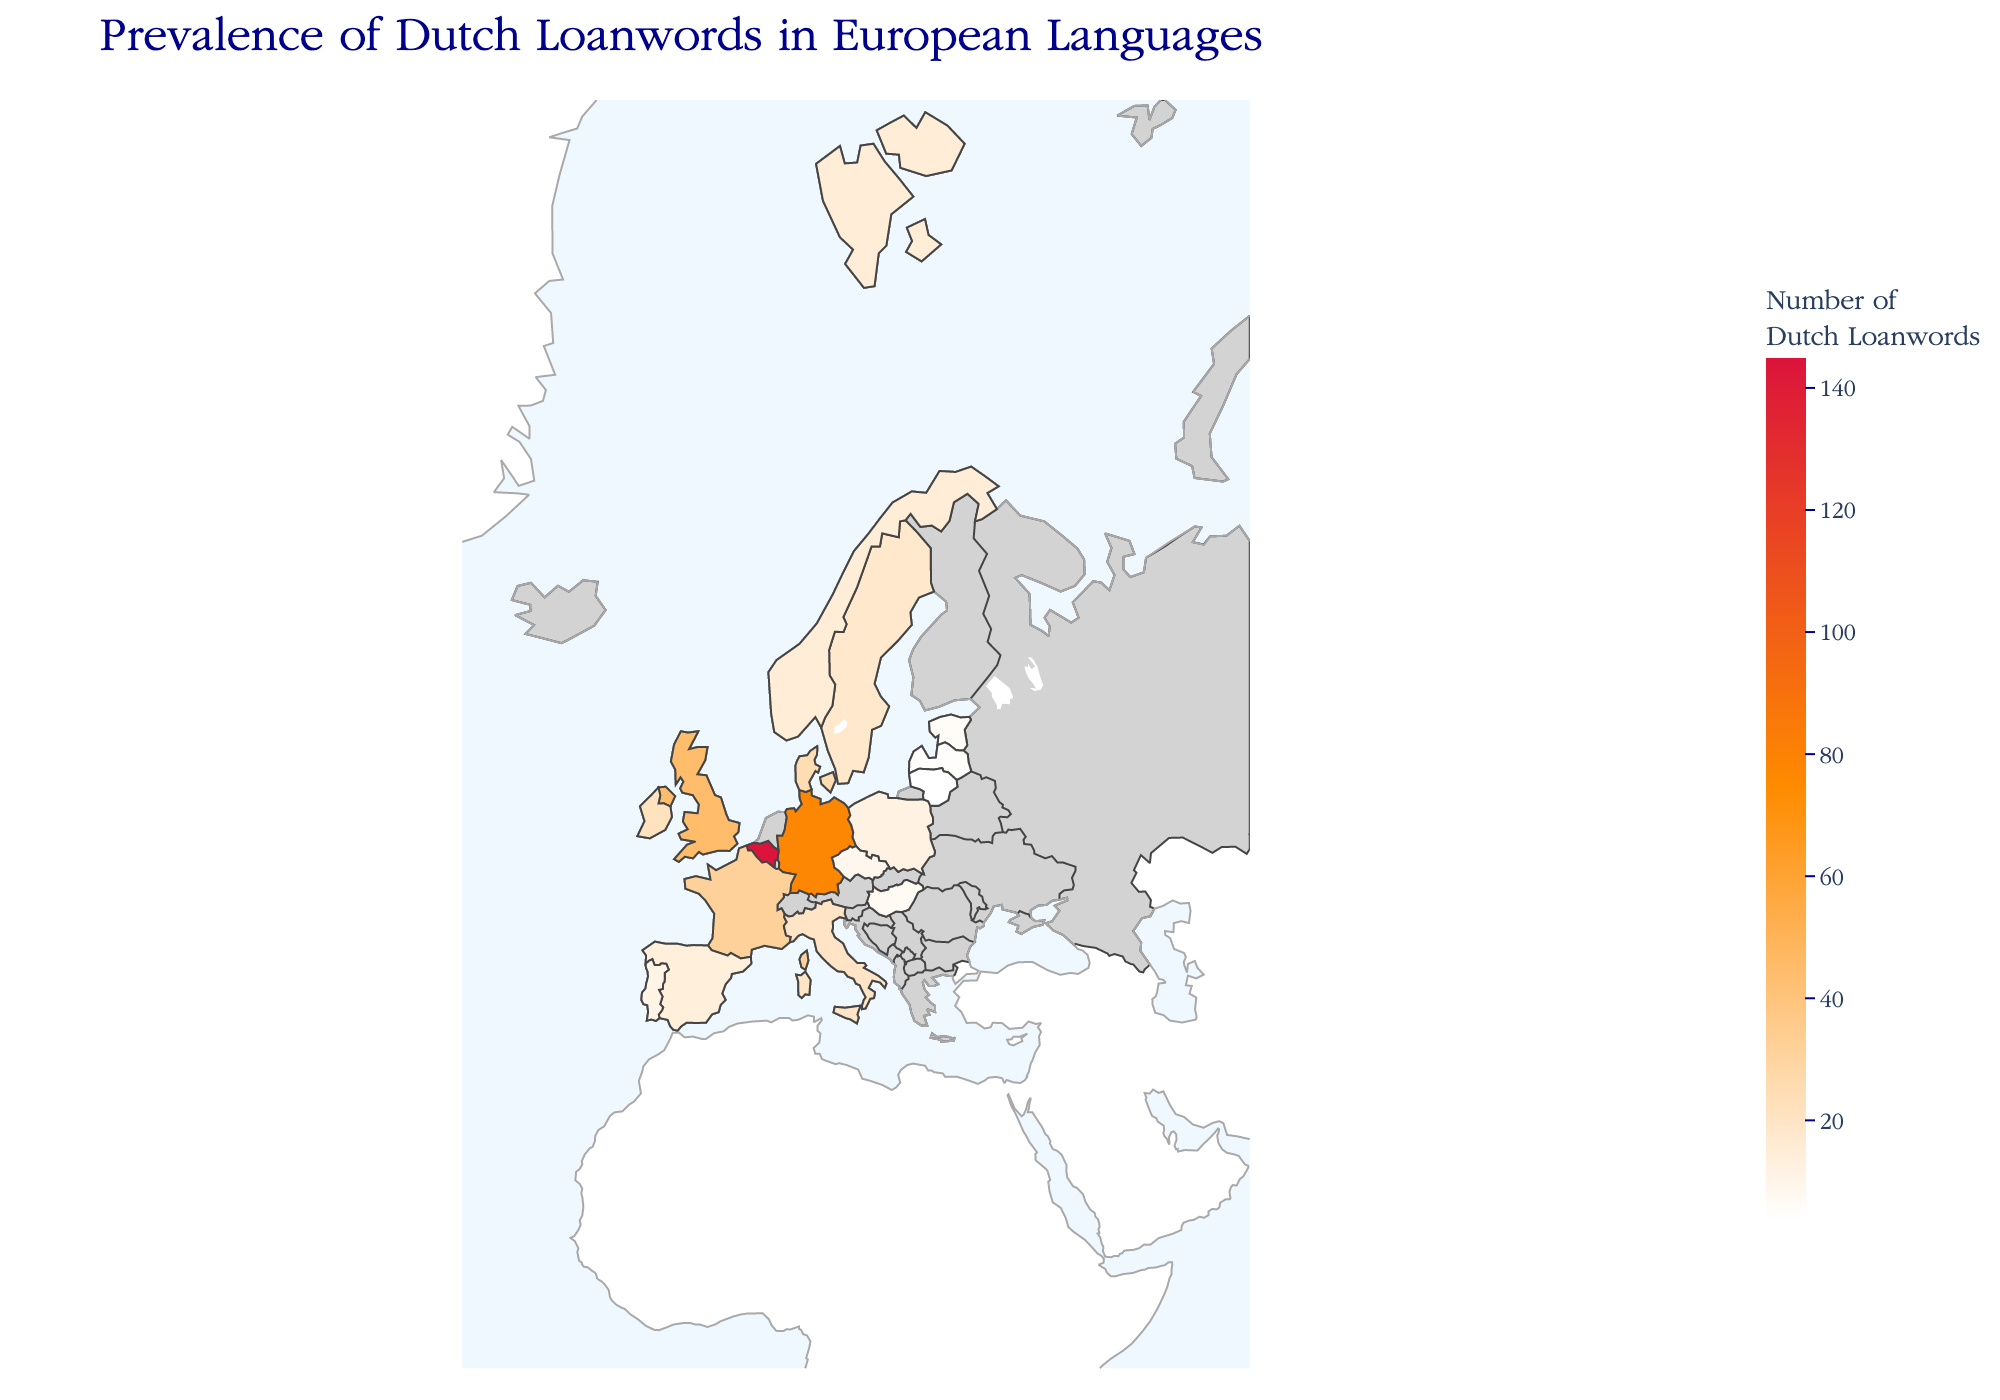What is the title of the figure? The title of the figure is usually displayed prominently at the top of the plot.
Answer: Prevalence of Dutch Loanwords in European Languages Which country has the highest number of Dutch loanwords? By looking at the color intensity on the plot, darker shades indicate higher values. Belgium stands out with the darkest shade.
Answer: Belgium How many Dutch loanwords are present in Germany? Hovering over Germany or finding it on the plot's choropleth will display the number of Dutch loanwords.
Answer: 78 Which regions are included in the figure? The boundaries and names of regions, like Western Europe, Northern Europe, etc., can be identified from the plot's annotated labels or by grouping countries geographically.
Answer: Western Europe, Northern Europe, Eastern Europe, Southern Europe, British Isles, Baltic States What is the difference in the number of Dutch loanwords between France and Italy? Locate and compare the values of France (32) and Italy (20) directly from the plot to find the difference.
Answer: 12 Among the Baltic States, which country has the least number of Dutch loanwords? By comparing the values for Estonia, Latvia, and Lithuania, the country with the lowest value is identified.
Answer: Lithuania Which countries in Southern Europe have more than 10 Dutch loanwords? From the plot, check the values for countries tagged under Southern Europe, identifying those exceeding 10 loanwords.
Answer: Italy and Spain What are the average Dutch loanwords in the Northern Europe countries shown? Add up the Dutch loanwords for Sweden (18), Denmark (25), and Norway (15), then divide by the number of countries (3). (18 + 25 + 15) / 3 = 19.33
Answer: 19.33 How does the prevalence of Dutch loanwords in the United Kingdom compare to that in Ireland? By comparing the values given on the plot for the United Kingdom (45) and Ireland (22), the UK has a higher prevalence.
Answer: The United Kingdom has more Dutch loanwords than Ireland Which country has fewer Dutch loanwords: Poland or Portugal? Examine and compare the values of Poland (12) and Portugal (11) from the plot; Portugal has one less loanword.
Answer: Portugal 